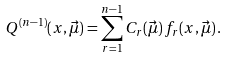Convert formula to latex. <formula><loc_0><loc_0><loc_500><loc_500>Q ^ { ( n - 1 ) } ( x , \vec { \mu } ) = \sum _ { r = 1 } ^ { n - 1 } C _ { r } ( \vec { \mu } ) \, f _ { r } ( x , \vec { \mu } ) \, .</formula> 